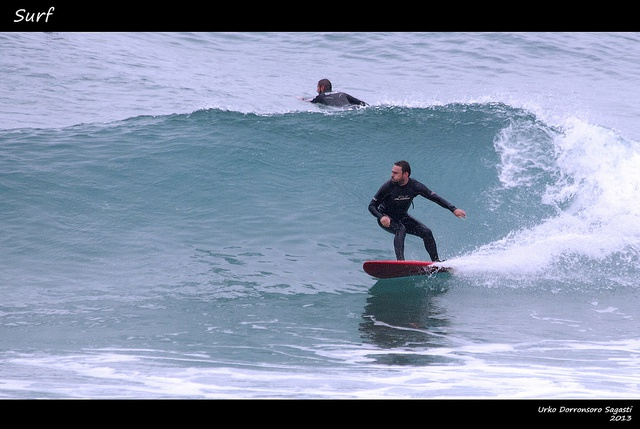Describe the objects in this image and their specific colors. I can see people in black and gray tones, surfboard in black, maroon, gray, and brown tones, and people in black and gray tones in this image. 